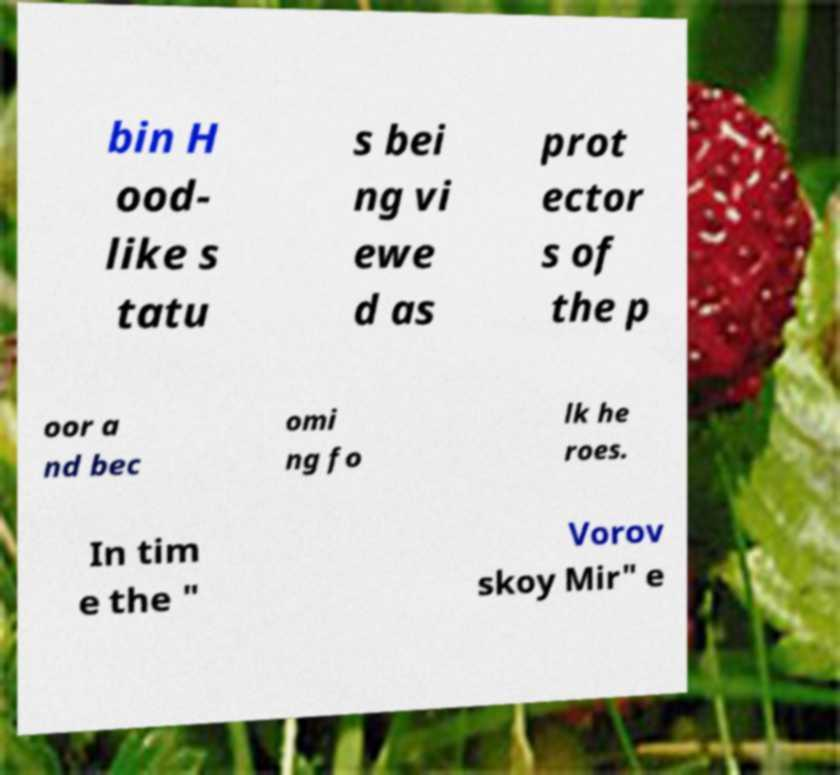Can you read and provide the text displayed in the image?This photo seems to have some interesting text. Can you extract and type it out for me? bin H ood- like s tatu s bei ng vi ewe d as prot ector s of the p oor a nd bec omi ng fo lk he roes. In tim e the " Vorov skoy Mir" e 